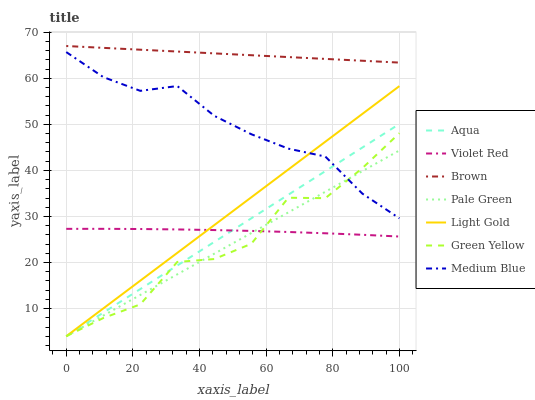Does Pale Green have the minimum area under the curve?
Answer yes or no. Yes. Does Brown have the maximum area under the curve?
Answer yes or no. Yes. Does Violet Red have the minimum area under the curve?
Answer yes or no. No. Does Violet Red have the maximum area under the curve?
Answer yes or no. No. Is Light Gold the smoothest?
Answer yes or no. Yes. Is Green Yellow the roughest?
Answer yes or no. Yes. Is Violet Red the smoothest?
Answer yes or no. No. Is Violet Red the roughest?
Answer yes or no. No. Does Violet Red have the lowest value?
Answer yes or no. No. Does Medium Blue have the highest value?
Answer yes or no. No. Is Aqua less than Brown?
Answer yes or no. Yes. Is Brown greater than Aqua?
Answer yes or no. Yes. Does Aqua intersect Brown?
Answer yes or no. No. 